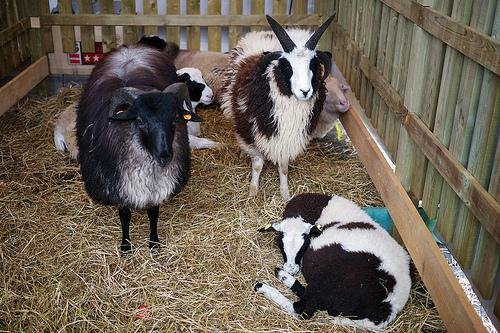Question: how many animals are shown?
Choices:
A. One.
B. Two.
C. Five.
D. Three.
Answer with the letter. Answer: C Question: where are the animals?
Choices:
A. Paster.
B. Barn.
C. Field.
D. A stall.
Answer with the letter. Answer: D Question: what is at the bottom of the stall?
Choices:
A. Dirt.
B. Chickens.
C. Floor.
D. Hay.
Answer with the letter. Answer: D Question: what are three of the animals doing?
Choices:
A. Running.
B. Sleeping.
C. Snuggling.
D. Laying.
Answer with the letter. Answer: D Question: what are two of the animals doing?
Choices:
A. Standing.
B. Sitting.
C. Jumping.
D. Walking.
Answer with the letter. Answer: A 